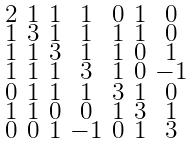Convert formula to latex. <formula><loc_0><loc_0><loc_500><loc_500>\begin{smallmatrix} 2 & 1 & 1 & 1 & 0 & 1 & 0 \\ 1 & 3 & 1 & 1 & 1 & 1 & 0 \\ 1 & 1 & 3 & 1 & 1 & 0 & 1 \\ 1 & 1 & 1 & 3 & 1 & 0 & - 1 \\ 0 & 1 & 1 & 1 & 3 & 1 & 0 \\ 1 & 1 & 0 & 0 & 1 & 3 & 1 \\ 0 & 0 & 1 & - 1 & 0 & 1 & 3 \end{smallmatrix}</formula> 